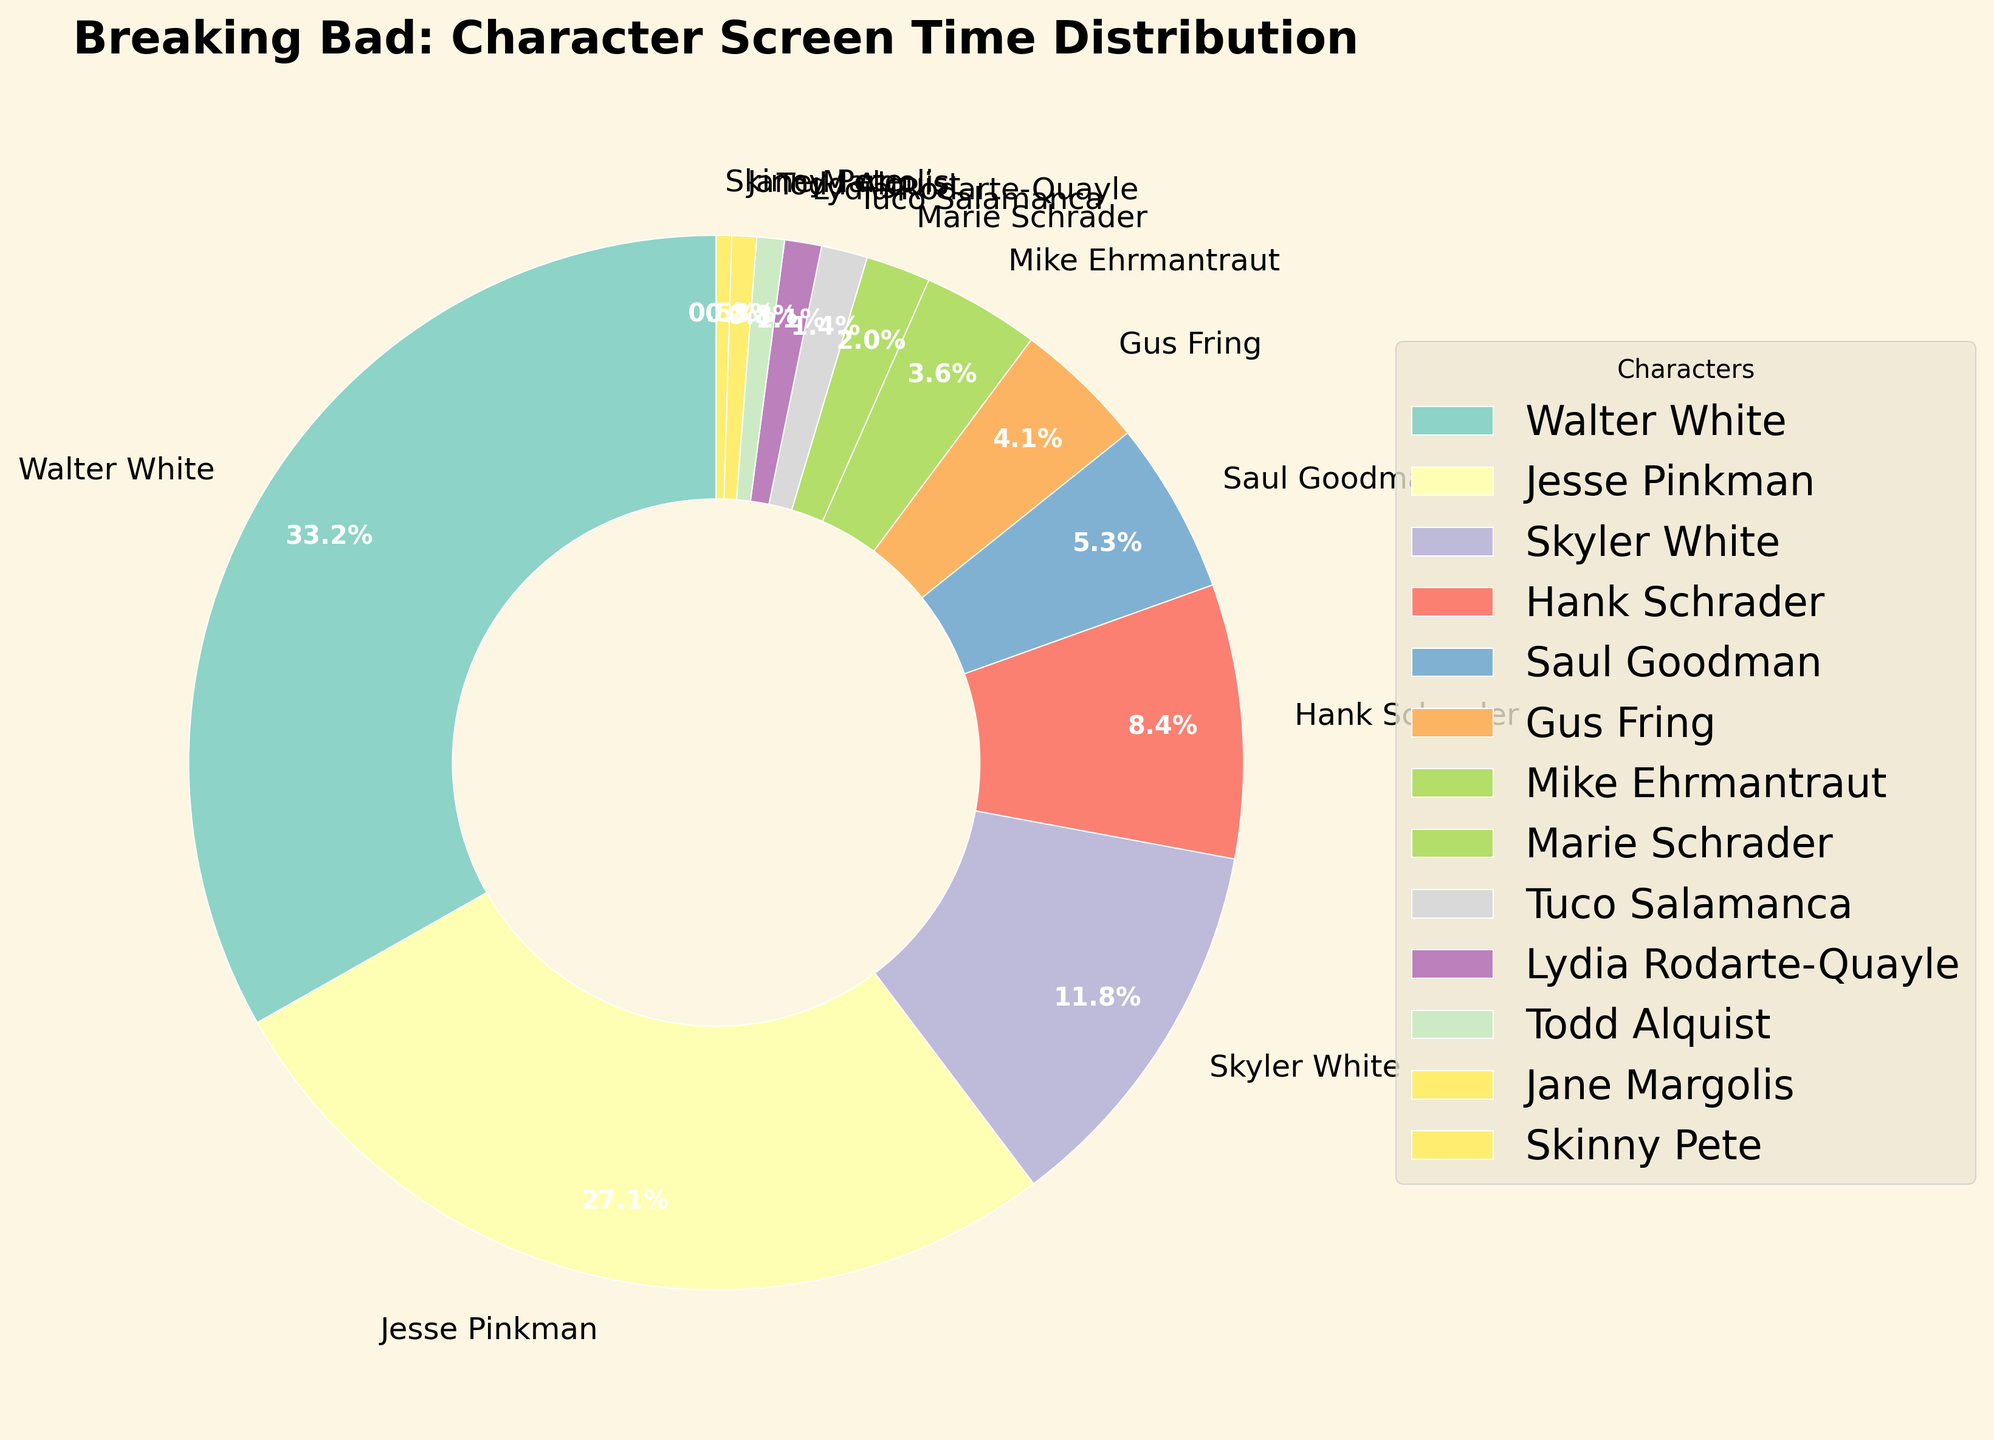Which character has the highest screen time percentage? Looking at the chart, the largest wedge belongs to Walter White with a screen time percentage of 35.2%, which is higher than any other character.
Answer: Walter White What's the combined screen time percentage for Skyler White and Hank Schrader? Skyler White has a screen time percentage of 12.5%, and Hank Schrader has 8.9%. Adding these together, 12.5 + 8.9 = 21.4%.
Answer: 21.4% Is Saul Goodman's screen time greater than Gus Fring's? Saul Goodman's screen time is 5.6%, and Gus Fring's is 4.3%. Since 5.6% is greater than 4.3%, Saul Goodman's screen time is indeed higher.
Answer: Yes How many characters have a screen time percentage less than 5%? The characters with less than 5% screen time are Gus Fring, Mike Ehrmantraut, Marie Schrader, Tuco Salamanca, Lydia Rodarte-Quayle, Todd Alquist, Jane Margolis, and Skinny Pete. Count all these characters: 8.
Answer: 8 What is the total screen time percentage for characters with less than 5% screen time? Sum of the screen time percentages: Gus Fring (4.3) + Mike Ehrmantraut (3.8) + Marie Schrader (2.1) + Tuco Salamanca (1.5) + Lydia Rodarte-Quayle (1.2) + Todd Alquist (0.9) + Jane Margolis (0.8) + Skinny Pete (0.5) = 15.1%.
Answer: 15.1% Who has more screen time, Jesse Pinkman or the combined total of Skyler White and Hank Schrader? Jesse Pinkman has a screen time percentage of 28.7%. The combined total of Skyler White and Hank Schrader is 12.5% + 8.9% = 21.4%. Since 28.7% is greater than 21.4%, Jesse Pinkman has more screen time.
Answer: Jesse Pinkman Which two characters combined have the closest screen time percentage to Walter White? Start with Skyler White (12.5%) and Hank Schrader (8.9%): 12.5 + 8.9 = 21.4%. Next, Skyler White and Jesse Pinkman: 12.5 + 28.7 = 41.2%. Gus Fring (4.3%) + Jesse Pinkman: 4.3 + 28.7 = 33%. Checking Mike Ehrmantraut (3.8%) + Jesse Pinkman: 3.8 + 28.7 = 32.5%. So, Mike Ehrmantraut and Jesse Pinkman combined (32.5%) is closest to Walter White's 35.2%.
Answer: Mike Ehrmantraut and Jesse Pinkman 